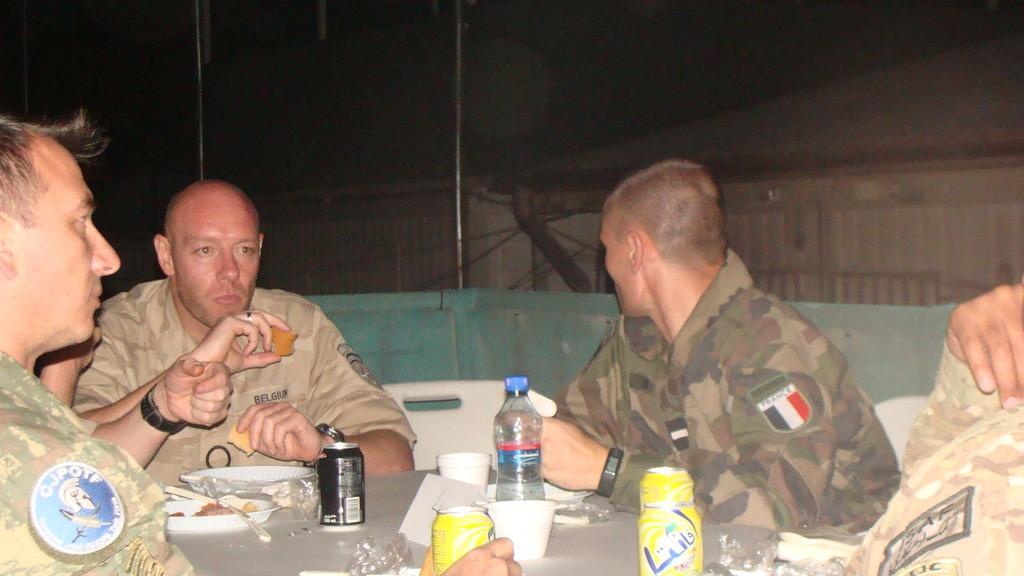Could you give a brief overview of what you see in this image? Here we can see a group of military people sitting on chairs with a table in front of them that is full of food and bottles of water and tins present on it and behind them we can see some houses 